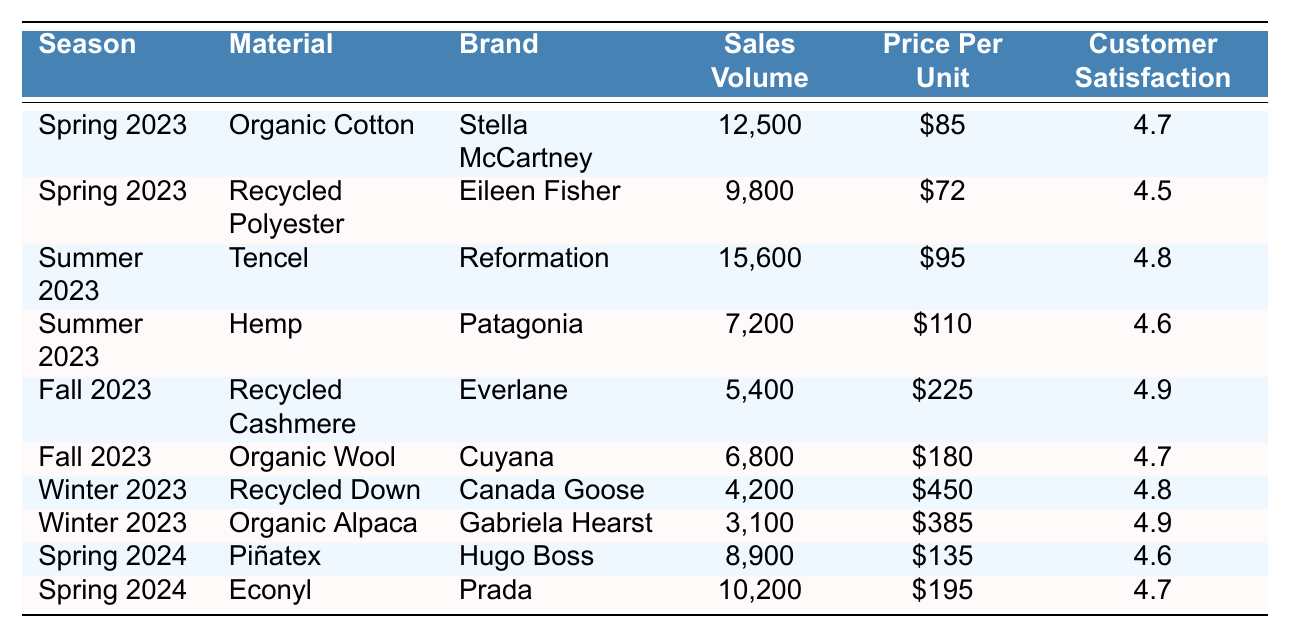What is the sales volume of Organic Cotton in Spring 2023? The table shows that Organic Cotton has a sales volume of 12,500 units during Spring 2023.
Answer: 12,500 Which brand sold the most in Summer 2023? In Summer 2023, Reformation sold Tencel with a sales volume of 15,600 units, which is the highest among all listed.
Answer: Reformation What was the price per unit for Recycled Cashmere? According to the table, Recycled Cashmere by Everlane was priced at $225 per unit.
Answer: $225 What is the customer satisfaction rating for Organic Alpaca? The table indicates that Organic Alpaca by Gabriela Hearst has a customer satisfaction rating of 4.9.
Answer: 4.9 What is the total sales volume for the Spring 2024 materials combined? To find the total, add the sales volumes of Piñatex (8,900) and Econyl (10,200), resulting in a total of 19,100 units.
Answer: 19,100 Which season had the least customer satisfaction rating and what was it? Inspecting the table, Fall 2023 has a customer satisfaction rating of 4.7 for Organic Wool, which is lower than the ratings for other seasons.
Answer: 4.7 How does the price per unit of Hemp compare to that of Tencel? Hemp is priced at $110 per unit while Tencel is $95 per unit, meaning Hemp is $15 higher than Tencel.
Answer: Hemp is $15 higher What is the average customer satisfaction rating for the materials sold in Winter 2023? The customer satisfaction ratings for Winter 2023 are 4.8 (Recycled Down) and 4.9 (Organic Alpaca). The average is (4.8 + 4.9) / 2 = 4.85.
Answer: 4.85 Which material had the highest sales volume in Fall 2023? In Fall 2023, Organic Wool had the highest sales volume at 6,800 units, superior to Recycled Cashmere's 5,400 units.
Answer: Organic Wool Is it true that the sales volume of Recycled Polyester is higher than that of Hemp? Comparing the sales volumes, Recycled Polyester had 9,800 units while Hemp had 7,200 units, confirming that the statement is true.
Answer: Yes 